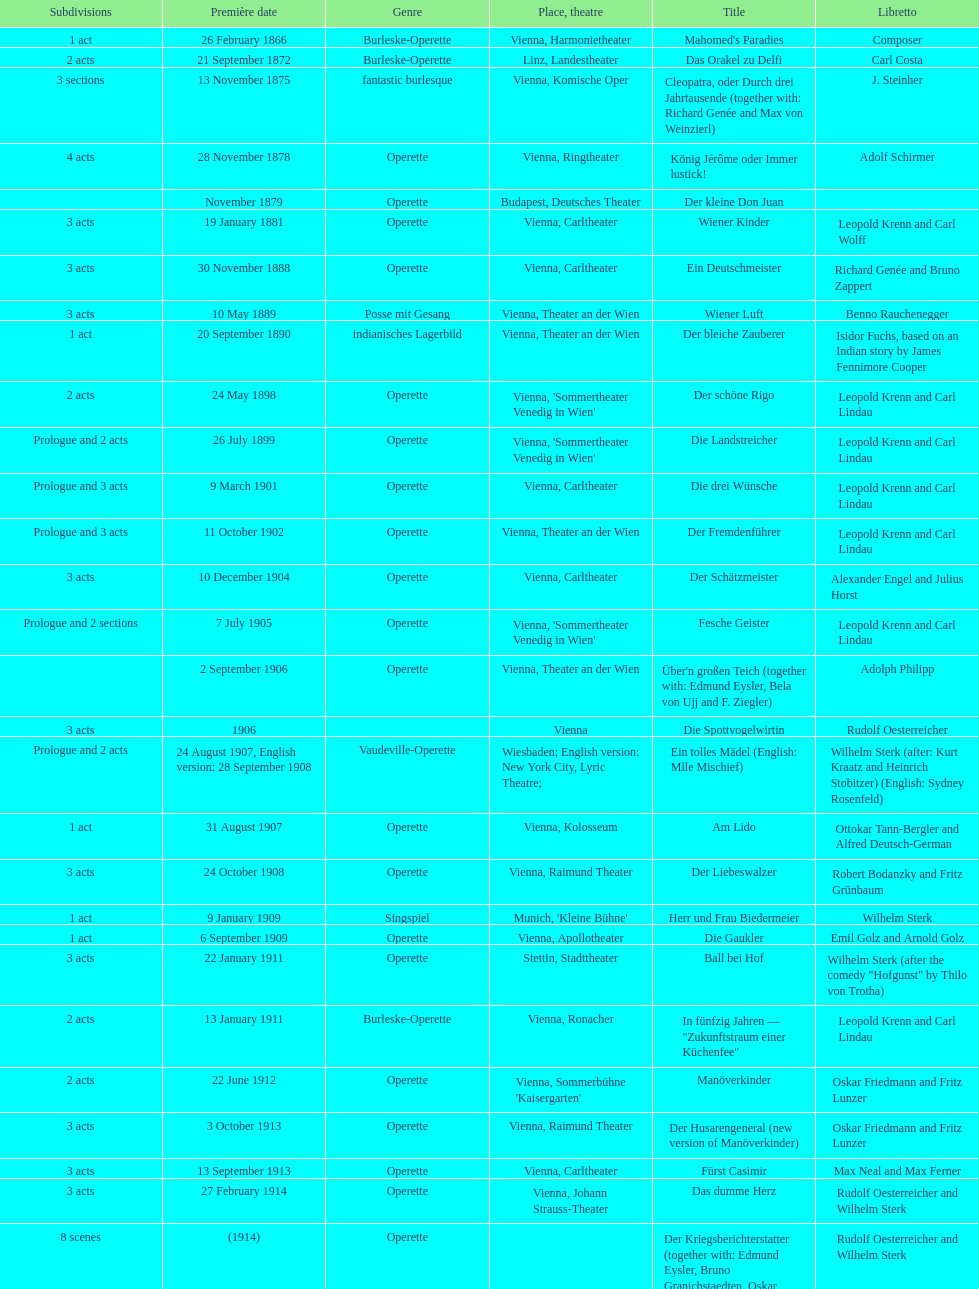How many of his operettas were 3 acts? 13. 